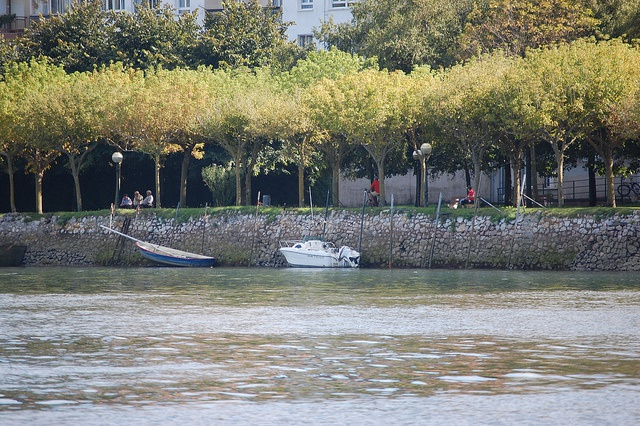Describe the objects in this image and their specific colors. I can see boat in gray, lavender, lightblue, and darkgray tones, boat in gray, darkgray, navy, and lightgray tones, bicycle in gray, black, and darkblue tones, people in gray, brown, and black tones, and people in gray, black, and brown tones in this image. 